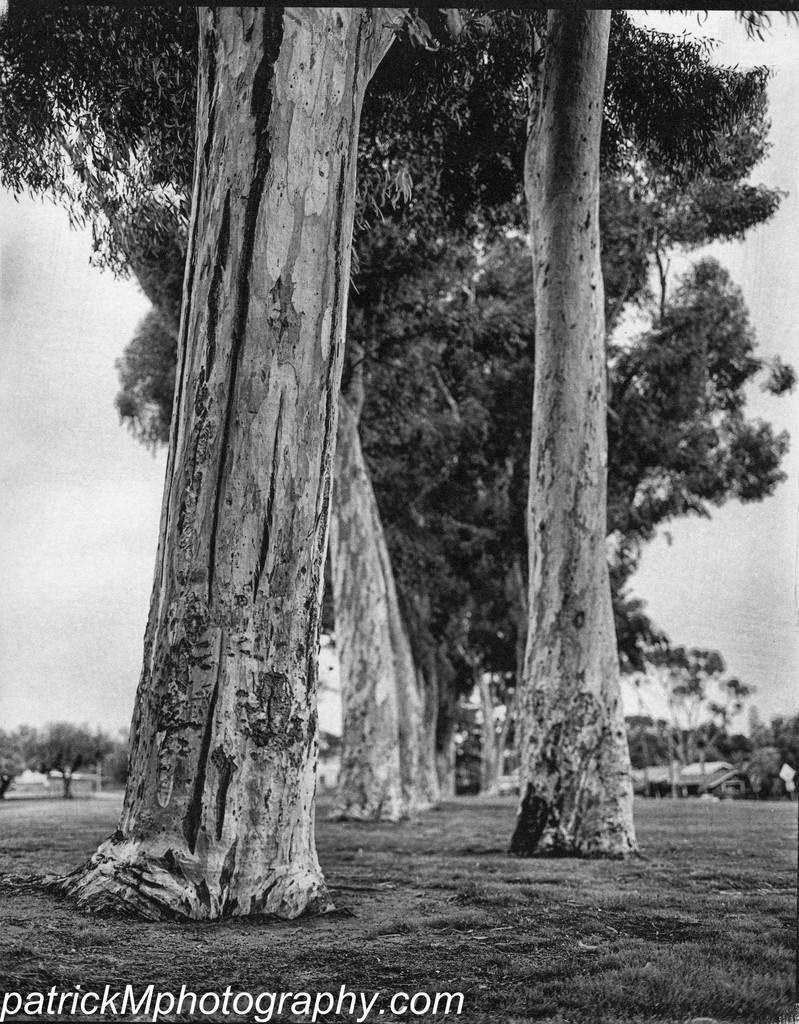What is the color scheme of the image? The image is black and white. What type of natural elements can be seen in the image? There are trees in the image. What type of man-made structures are present in the image? There are houses in the image. What is visible in the background of the image? The sky is visible in the background of the image. What is written or displayed at the bottom of the image? There is text at the bottom of the image. How many mailboxes are visible in the image? There is no mailbox present in the image. What type of trouble can be seen in the image? There is no trouble depicted in the image; it is a black and white scene featuring trees, houses, the sky, and text. 